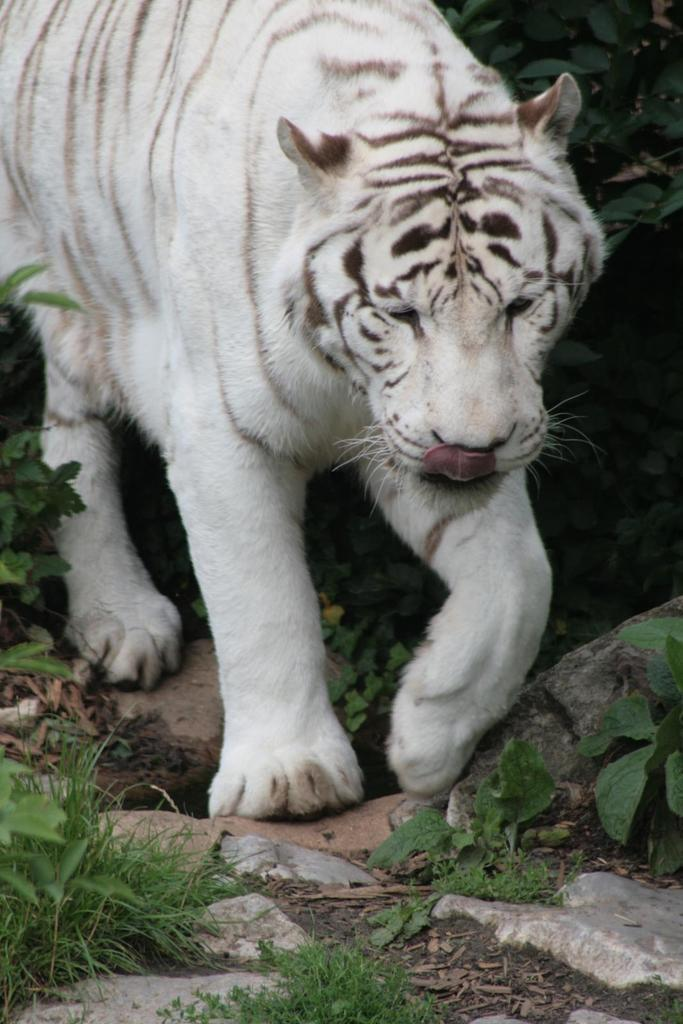What type of animal is in the image? There is a white tiger in the image. Where is the tiger located in the image? The tiger is on the ground in the image. What type of terrain can be seen in the image? There are stones and grass visible in the image. What type of vegetation is present in the image? There are plants in the image. What type of rhythm can be heard in the image? There is no sound or rhythm present in the image, as it is a still photograph. 